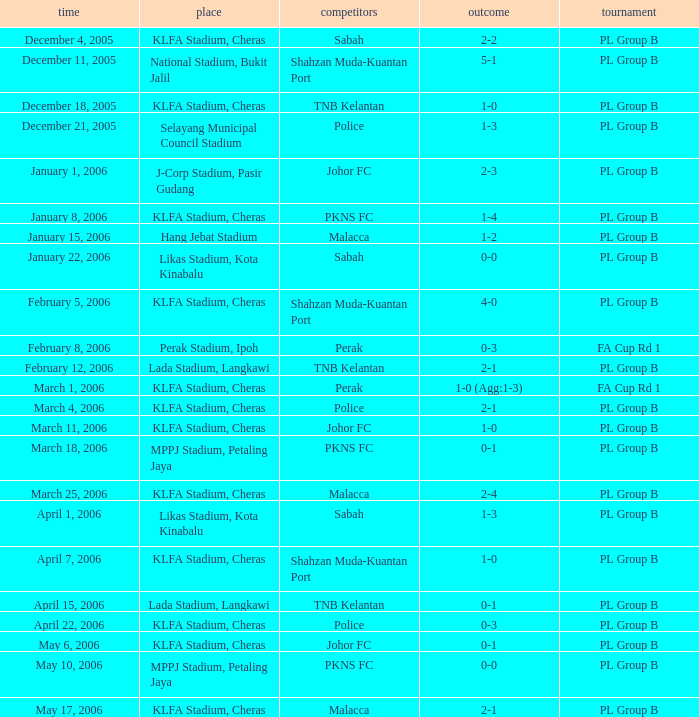Which Date has a Competition of pl group b, and Opponents of police, and a Venue of selayang municipal council stadium? December 21, 2005. 